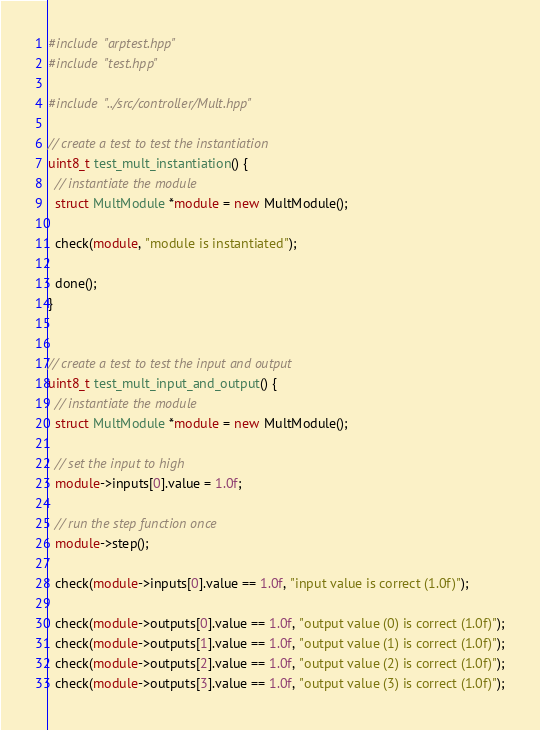Convert code to text. <code><loc_0><loc_0><loc_500><loc_500><_C++_>#include "arptest.hpp"
#include "test.hpp"

#include "../src/controller/Mult.hpp"

// create a test to test the instantiation
uint8_t test_mult_instantiation() {
  // instantiate the module
  struct MultModule *module = new MultModule();

  check(module, "module is instantiated");

  done();
}


// create a test to test the input and output
uint8_t test_mult_input_and_output() {
  // instantiate the module
  struct MultModule *module = new MultModule();

  // set the input to high
  module->inputs[0].value = 1.0f;

  // run the step function once
  module->step();

  check(module->inputs[0].value == 1.0f, "input value is correct (1.0f)");

  check(module->outputs[0].value == 1.0f, "output value (0) is correct (1.0f)");
  check(module->outputs[1].value == 1.0f, "output value (1) is correct (1.0f)");
  check(module->outputs[2].value == 1.0f, "output value (2) is correct (1.0f)");
  check(module->outputs[3].value == 1.0f, "output value (3) is correct (1.0f)");</code> 